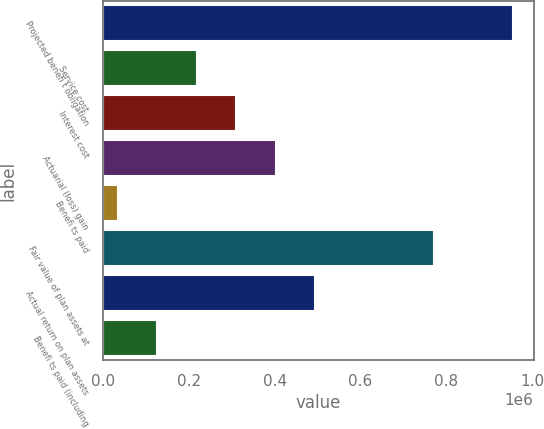Convert chart to OTSL. <chart><loc_0><loc_0><loc_500><loc_500><bar_chart><fcel>Projected benefi t obligation<fcel>Service cost<fcel>Interest cost<fcel>Actuarial (loss) gain<fcel>Benefi ts paid<fcel>Fair value of plan assets at<fcel>Actual return on plan assets<fcel>Benefi ts paid (including<nl><fcel>956172<fcel>218058<fcel>310322<fcel>402586<fcel>33529<fcel>771643<fcel>494850<fcel>125793<nl></chart> 